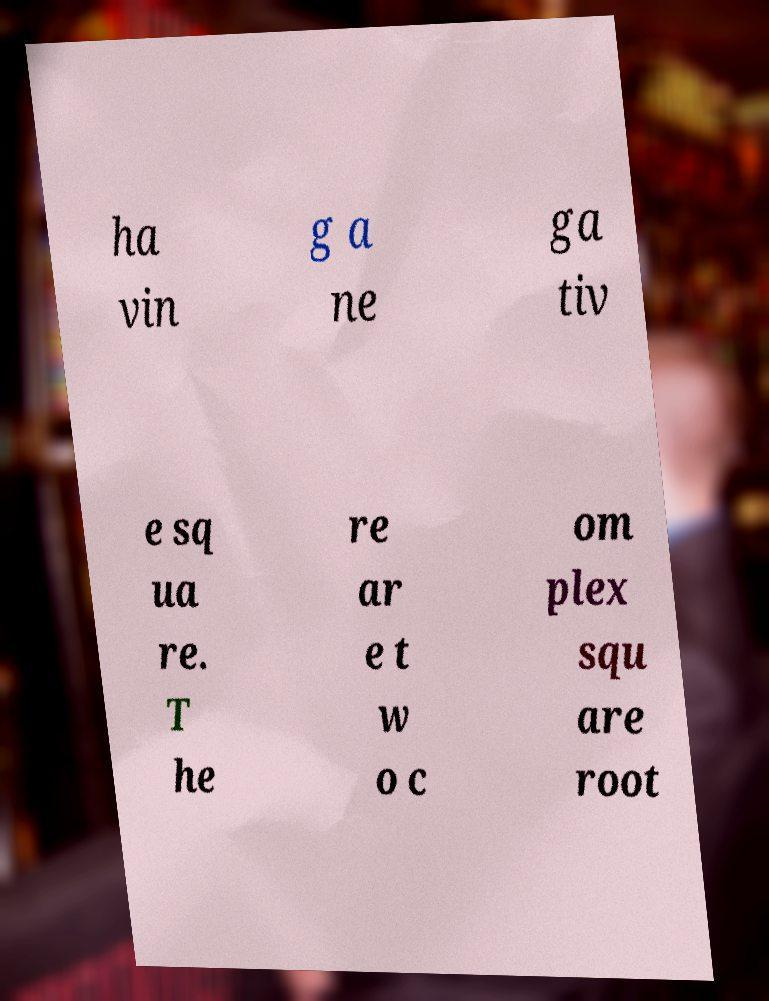For documentation purposes, I need the text within this image transcribed. Could you provide that? ha vin g a ne ga tiv e sq ua re. T he re ar e t w o c om plex squ are root 